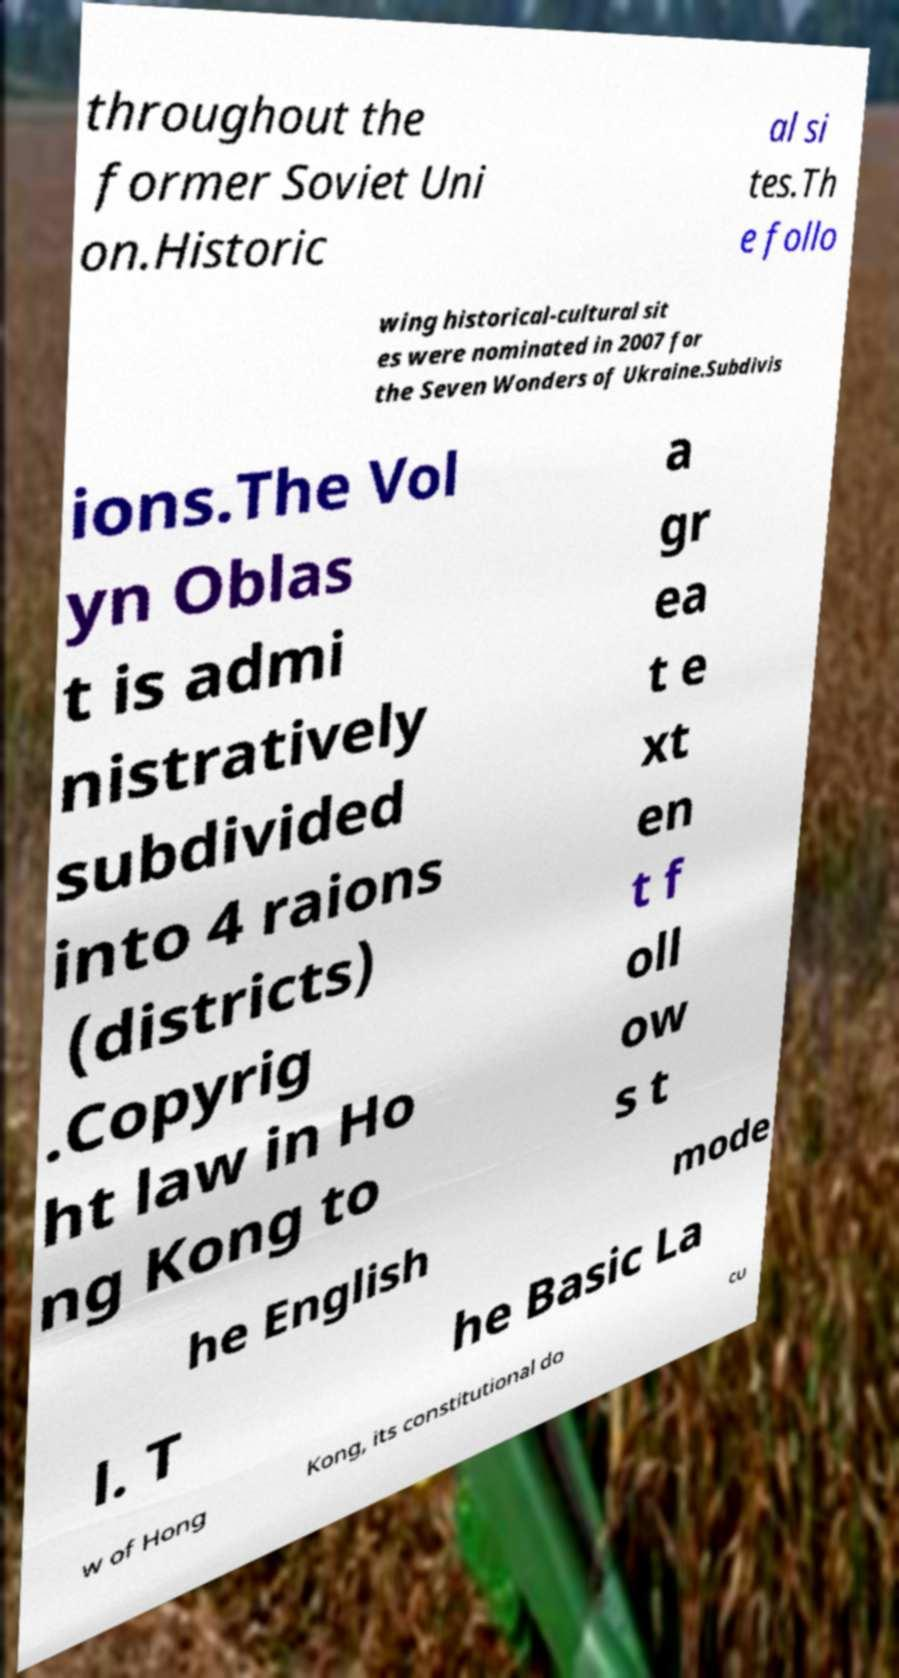There's text embedded in this image that I need extracted. Can you transcribe it verbatim? throughout the former Soviet Uni on.Historic al si tes.Th e follo wing historical-cultural sit es were nominated in 2007 for the Seven Wonders of Ukraine.Subdivis ions.The Vol yn Oblas t is admi nistratively subdivided into 4 raions (districts) .Copyrig ht law in Ho ng Kong to a gr ea t e xt en t f oll ow s t he English mode l. T he Basic La w of Hong Kong, its constitutional do cu 